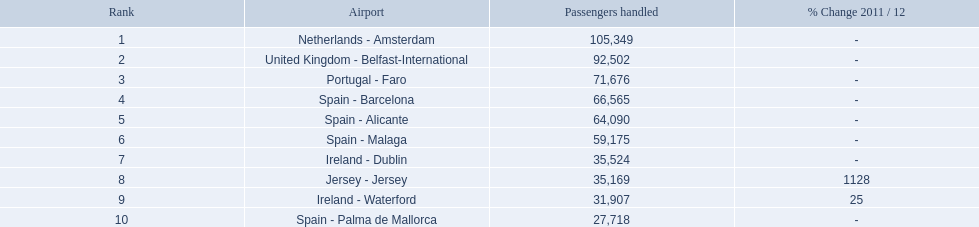What are the numbers of passengers handled along the different routes in the airport? 105,349, 92,502, 71,676, 66,565, 64,090, 59,175, 35,524, 35,169, 31,907, 27,718. Of these routes, which handles less than 30,000 passengers? Spain - Palma de Mallorca. Write the full table. {'header': ['Rank', 'Airport', 'Passengers handled', '% Change 2011 / 12'], 'rows': [['1', 'Netherlands - Amsterdam', '105,349', '-'], ['2', 'United Kingdom - Belfast-International', '92,502', '-'], ['3', 'Portugal - Faro', '71,676', '-'], ['4', 'Spain - Barcelona', '66,565', '-'], ['5', 'Spain - Alicante', '64,090', '-'], ['6', 'Spain - Malaga', '59,175', '-'], ['7', 'Ireland - Dublin', '35,524', '-'], ['8', 'Jersey - Jersey', '35,169', '1128'], ['9', 'Ireland - Waterford', '31,907', '25'], ['10', 'Spain - Palma de Mallorca', '27,718', '-']]} What are the passenger figures for the different airport routes? 105,349, 92,502, 71,676, 66,565, 64,090, 59,175, 35,524, 35,169, 31,907, 27,718. Out of these routes, which one has less than 30,000 passengers? Spain - Palma de Mallorca. What are the counts of passengers accommodated along the distinct routes in the airport? 105,349, 92,502, 71,676, 66,565, 64,090, 59,175, 35,524, 35,169, 31,907, 27,718. Among these routes, which handles under 30,000 passengers? Spain - Palma de Mallorca. What are all the airports? Netherlands - Amsterdam, United Kingdom - Belfast-International, Portugal - Faro, Spain - Barcelona, Spain - Alicante, Spain - Malaga, Ireland - Dublin, Jersey - Jersey, Ireland - Waterford, Spain - Palma de Mallorca. How many passengers have they processed? 105,349, 92,502, 71,676, 66,565, 64,090, 59,175, 35,524, 35,169, 31,907, 27,718. And which airport has processed the most passengers? Netherlands - Amsterdam. 